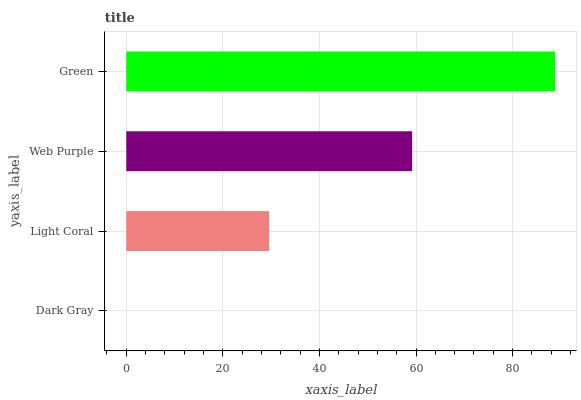Is Dark Gray the minimum?
Answer yes or no. Yes. Is Green the maximum?
Answer yes or no. Yes. Is Light Coral the minimum?
Answer yes or no. No. Is Light Coral the maximum?
Answer yes or no. No. Is Light Coral greater than Dark Gray?
Answer yes or no. Yes. Is Dark Gray less than Light Coral?
Answer yes or no. Yes. Is Dark Gray greater than Light Coral?
Answer yes or no. No. Is Light Coral less than Dark Gray?
Answer yes or no. No. Is Web Purple the high median?
Answer yes or no. Yes. Is Light Coral the low median?
Answer yes or no. Yes. Is Green the high median?
Answer yes or no. No. Is Web Purple the low median?
Answer yes or no. No. 